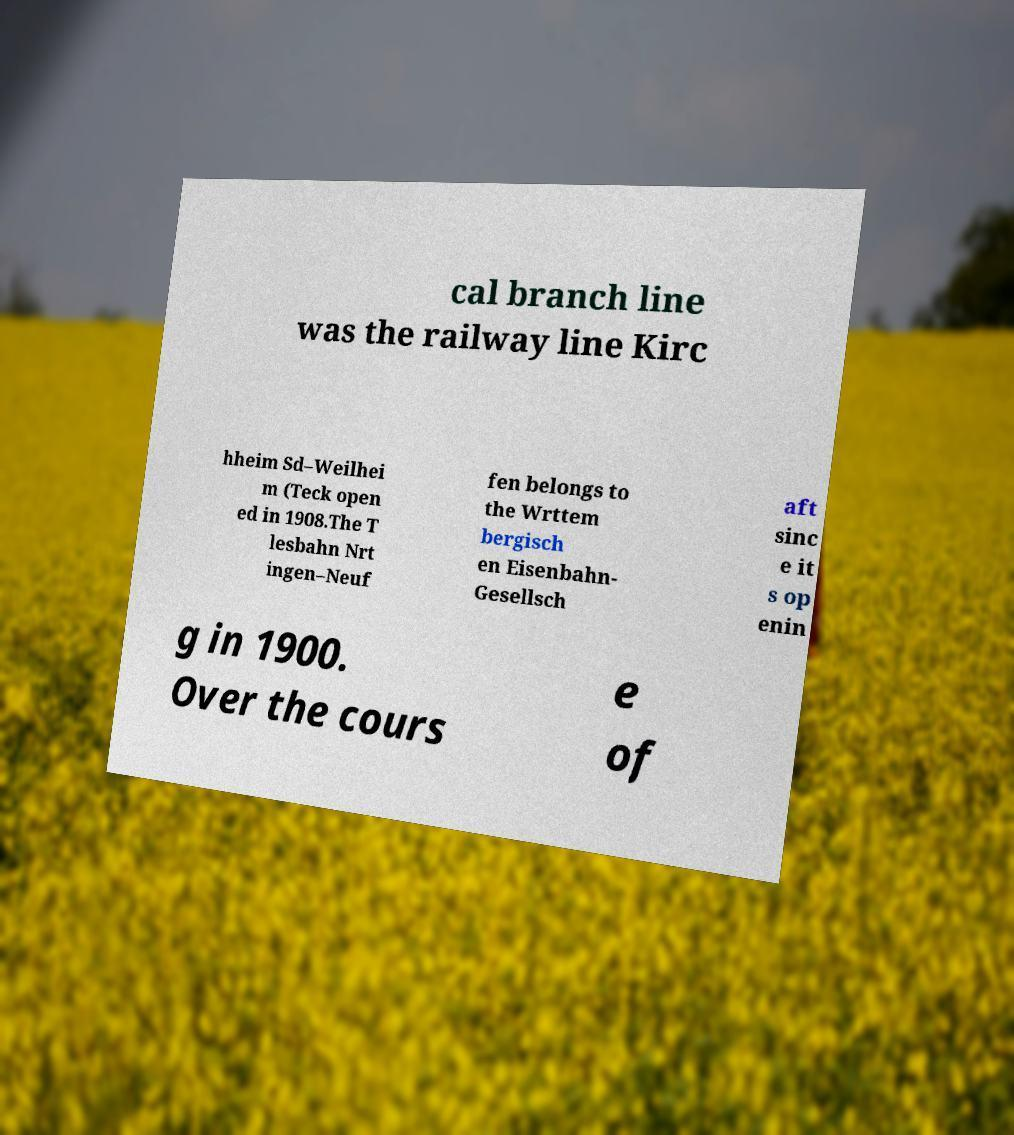For documentation purposes, I need the text within this image transcribed. Could you provide that? cal branch line was the railway line Kirc hheim Sd–Weilhei m (Teck open ed in 1908.The T lesbahn Nrt ingen–Neuf fen belongs to the Wrttem bergisch en Eisenbahn- Gesellsch aft sinc e it s op enin g in 1900. Over the cours e of 